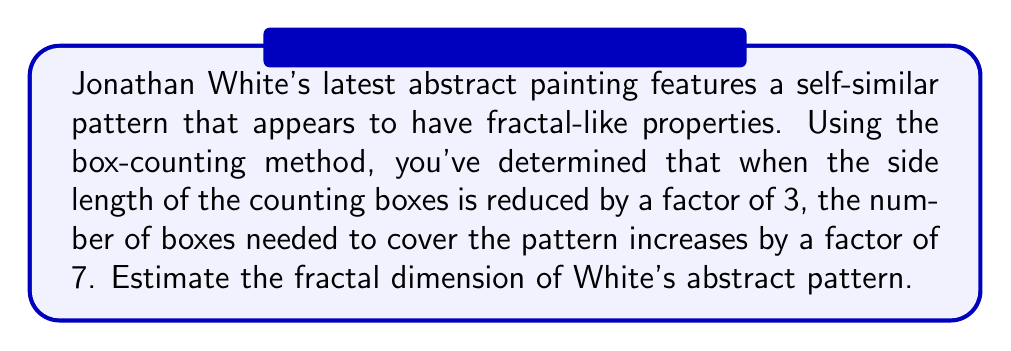Give your solution to this math problem. To estimate the fractal dimension using the box-counting method, we can use the following steps:

1. Recall the formula for fractal dimension $D$ using the box-counting method:

   $$D = \frac{\log(N)}{\log(1/r)}$$

   where $N$ is the factor by which the number of boxes increases, and $1/r$ is the factor by which the box size is reduced.

2. In this case, we have:
   - $N = 7$ (the number of boxes increases by a factor of 7)
   - $1/r = 3$ (the box size is reduced by a factor of 3)

3. Substituting these values into the formula:

   $$D = \frac{\log(7)}{\log(3)}$$

4. Calculate the logarithms:
   
   $$D = \frac{0.8450980400142568}{0.4771212547196624}$$

5. Perform the division:

   $$D \approx 1.7712$$

6. Round to two decimal places:

   $$D \approx 1.77$$

This value represents the estimated fractal dimension of White's abstract pattern.
Answer: 1.77 